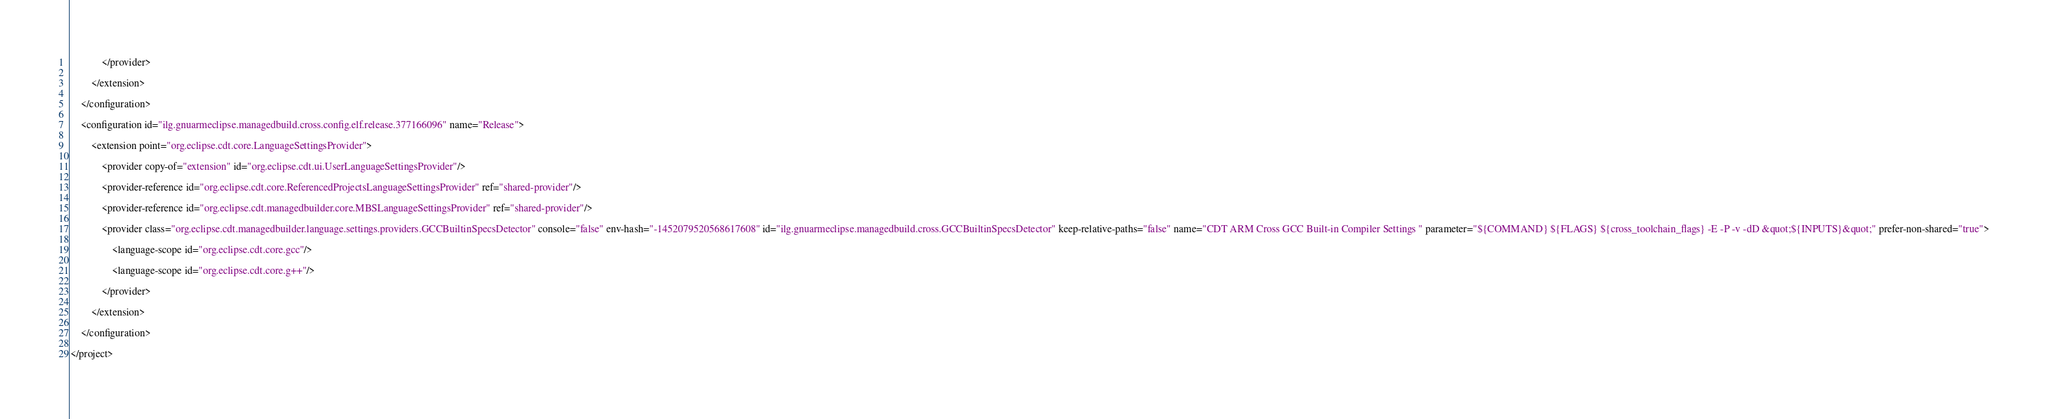Convert code to text. <code><loc_0><loc_0><loc_500><loc_500><_XML_>            </provider>
            		
        </extension>
        	
    </configuration>
    	
    <configuration id="ilg.gnuarmeclipse.managedbuild.cross.config.elf.release.377166096" name="Release">
        		
        <extension point="org.eclipse.cdt.core.LanguageSettingsProvider">
            			
            <provider copy-of="extension" id="org.eclipse.cdt.ui.UserLanguageSettingsProvider"/>
            			
            <provider-reference id="org.eclipse.cdt.core.ReferencedProjectsLanguageSettingsProvider" ref="shared-provider"/>
            			
            <provider-reference id="org.eclipse.cdt.managedbuilder.core.MBSLanguageSettingsProvider" ref="shared-provider"/>
            			
            <provider class="org.eclipse.cdt.managedbuilder.language.settings.providers.GCCBuiltinSpecsDetector" console="false" env-hash="-1452079520568617608" id="ilg.gnuarmeclipse.managedbuild.cross.GCCBuiltinSpecsDetector" keep-relative-paths="false" name="CDT ARM Cross GCC Built-in Compiler Settings " parameter="${COMMAND} ${FLAGS} ${cross_toolchain_flags} -E -P -v -dD &quot;${INPUTS}&quot;" prefer-non-shared="true">
                				
                <language-scope id="org.eclipse.cdt.core.gcc"/>
                				
                <language-scope id="org.eclipse.cdt.core.g++"/>
                			
            </provider>
            		
        </extension>
        	
    </configuration>
    
</project>
</code> 